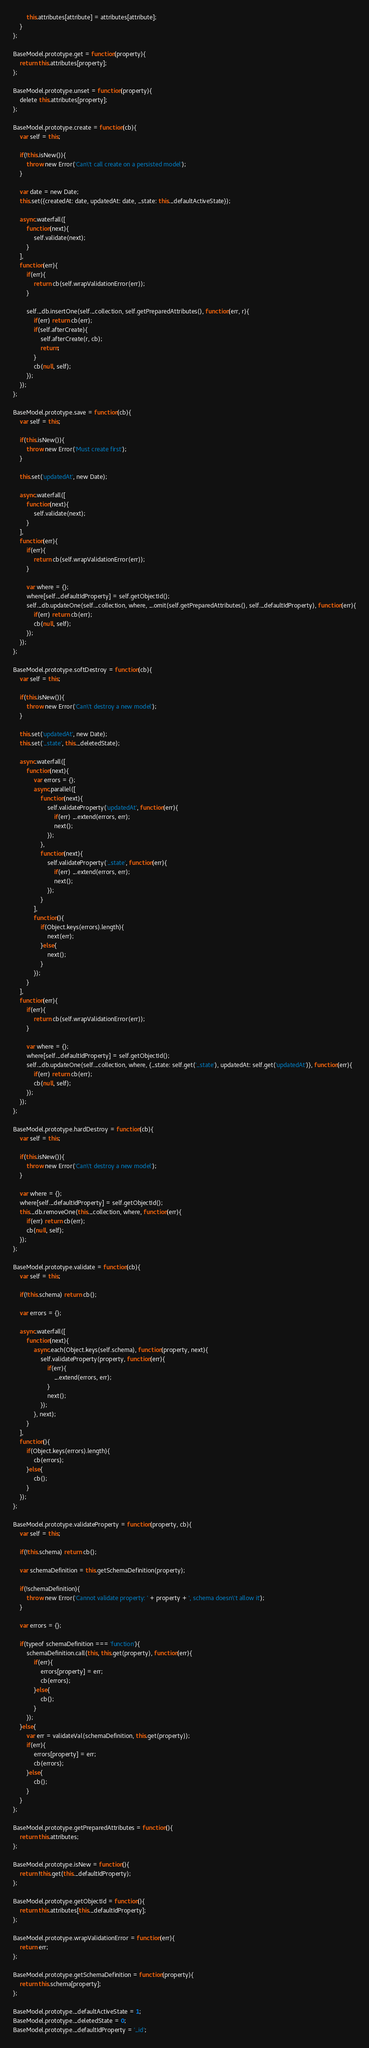Convert code to text. <code><loc_0><loc_0><loc_500><loc_500><_JavaScript_>		this.attributes[attribute] = attributes[attribute];
	}
};

BaseModel.prototype.get = function(property){
	return this.attributes[property];
};

BaseModel.prototype.unset = function(property){
	delete this.attributes[property];
};

BaseModel.prototype.create = function(cb){
	var self = this;

	if(!this.isNew()){
		throw new Error('Can\'t call create on a persisted model');
	}

	var date = new Date;
	this.set({createdAt: date, updatedAt: date, _state: this._defaultActiveState});

	async.waterfall([
		function(next){
			self.validate(next);
		}
	],
	function(err){
		if(err){
			return cb(self.wrapValidationError(err));
		}

		self._db.insertOne(self._collection, self.getPreparedAttributes(), function(err, r){
			if(err) return cb(err);
			if(self.afterCreate){
				self.afterCreate(r, cb);
				return;
			}
			cb(null, self);
		});
	});
};

BaseModel.prototype.save = function(cb){
	var self = this;

	if(this.isNew()){
		throw new Error('Must create first');
	}

	this.set('updatedAt', new Date);

	async.waterfall([
		function(next){
			self.validate(next);
		}
	],
	function(err){
		if(err){
			return cb(self.wrapValidationError(err));
		}

		var where = {};
		where[self._defaultIdProperty] = self.getObjectId();
		self._db.updateOne(self._collection, where, _.omit(self.getPreparedAttributes(), self._defaultIdProperty), function(err){
			if(err) return cb(err);
			cb(null, self);
		});
	});
};

BaseModel.prototype.softDestroy = function(cb){
	var self = this;

	if(this.isNew()){
		throw new Error('Can\'t destroy a new model');
	}

	this.set('updatedAt', new Date);
	this.set('_state', this._deletedState);

	async.waterfall([
		function(next){
			var errors = {};
			async.parallel([
				function(next){
					self.validateProperty('updatedAt', function(err){
						if(err) _.extend(errors, err);
						next();
					});
				},
				function(next){
					self.validateProperty('_state', function(err){
						if(err) _.extend(errors, err);
						next();
					});
				}
			],
			function(){
				if(Object.keys(errors).length){
					next(err);
				}else{
					next();
				}
			});
		}
	],
	function(err){
		if(err){
			return cb(self.wrapValidationError(err));
		}

		var where = {};
		where[self._defaultIdProperty] = self.getObjectId();
		self._db.updateOne(self._collection, where, {_state: self.get('_state'), updatedAt: self.get('updatedAt')}, function(err){
			if(err) return cb(err);
			cb(null, self);
		});
	});
};

BaseModel.prototype.hardDestroy = function(cb){
	var self = this;

	if(this.isNew()){
		throw new Error('Can\'t destroy a new model');
	}

	var where = {};
	where[self._defaultIdProperty] = self.getObjectId();
	this._db.removeOne(this._collection, where, function(err){
		if(err) return cb(err);
		cb(null, self);
	});
};

BaseModel.prototype.validate = function(cb){
	var self = this;

	if(!this.schema) return cb();

	var errors = {};

	async.waterfall([
		function(next){
			async.each(Object.keys(self.schema), function(property, next){
				self.validateProperty(property, function(err){
					if(err){
						_.extend(errors, err);
					}
					next();
				});
			}, next);
		}
	],
	function(){
		if(Object.keys(errors).length){
			cb(errors);
		}else{
			cb();
		}
	});
};

BaseModel.prototype.validateProperty = function(property, cb){
	var self = this;

	if(!this.schema) return cb();

	var schemaDefinition = this.getSchemaDefinition(property);

	if(!schemaDefinition){
		throw new Error('Cannot validate property: ' + property + ', schema doesn\'t allow it');
	}

	var errors = {};

	if(typeof schemaDefinition === 'function'){
		schemaDefinition.call(this, this.get(property), function(err){
			if(err){
				errors[property] = err;
				cb(errors);
			}else{
				cb();
			}
		});
	}else{
		var err = validateVal(schemaDefinition, this.get(property));
		if(err){
			errors[property] = err;
			cb(errors);
		}else{
			cb();
		}
	}
};

BaseModel.prototype.getPreparedAttributes = function(){
	return this.attributes;
};

BaseModel.prototype.isNew = function(){
	return !this.get(this._defaultIdProperty);
};

BaseModel.prototype.getObjectId = function(){
	return this.attributes[this._defaultIdProperty];
};

BaseModel.prototype.wrapValidationError = function(err){
	return err;
};

BaseModel.prototype.getSchemaDefinition = function(property){
	return this.schema[property];
};

BaseModel.prototype._defaultActiveState = 1;
BaseModel.prototype._deletedState = 0;
BaseModel.prototype._defaultIdProperty = '_id';
</code> 